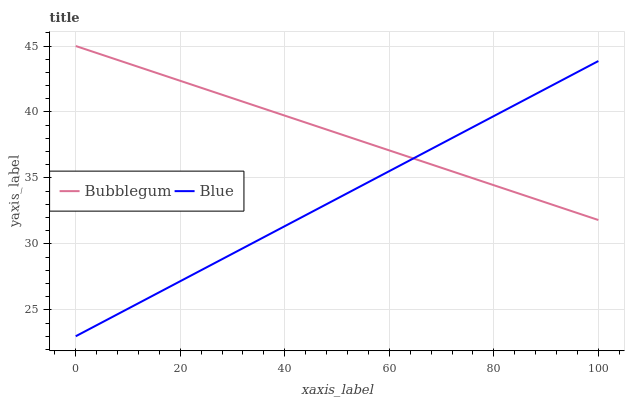Does Blue have the minimum area under the curve?
Answer yes or no. Yes. Does Bubblegum have the maximum area under the curve?
Answer yes or no. Yes. Does Bubblegum have the minimum area under the curve?
Answer yes or no. No. Is Blue the smoothest?
Answer yes or no. Yes. Is Bubblegum the roughest?
Answer yes or no. Yes. Is Bubblegum the smoothest?
Answer yes or no. No. Does Blue have the lowest value?
Answer yes or no. Yes. Does Bubblegum have the lowest value?
Answer yes or no. No. Does Bubblegum have the highest value?
Answer yes or no. Yes. Does Blue intersect Bubblegum?
Answer yes or no. Yes. Is Blue less than Bubblegum?
Answer yes or no. No. Is Blue greater than Bubblegum?
Answer yes or no. No. 